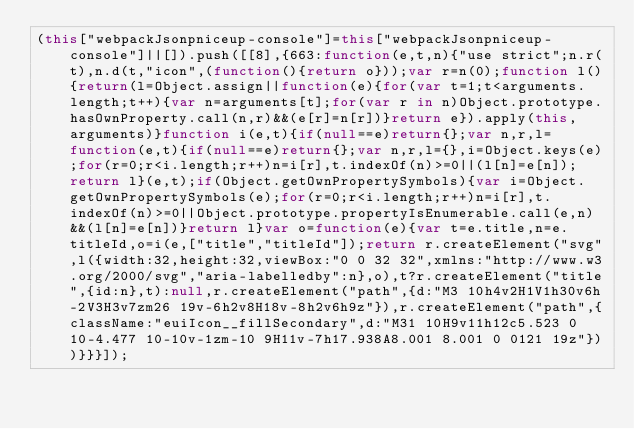Convert code to text. <code><loc_0><loc_0><loc_500><loc_500><_JavaScript_>(this["webpackJsonpniceup-console"]=this["webpackJsonpniceup-console"]||[]).push([[8],{663:function(e,t,n){"use strict";n.r(t),n.d(t,"icon",(function(){return o}));var r=n(0);function l(){return(l=Object.assign||function(e){for(var t=1;t<arguments.length;t++){var n=arguments[t];for(var r in n)Object.prototype.hasOwnProperty.call(n,r)&&(e[r]=n[r])}return e}).apply(this,arguments)}function i(e,t){if(null==e)return{};var n,r,l=function(e,t){if(null==e)return{};var n,r,l={},i=Object.keys(e);for(r=0;r<i.length;r++)n=i[r],t.indexOf(n)>=0||(l[n]=e[n]);return l}(e,t);if(Object.getOwnPropertySymbols){var i=Object.getOwnPropertySymbols(e);for(r=0;r<i.length;r++)n=i[r],t.indexOf(n)>=0||Object.prototype.propertyIsEnumerable.call(e,n)&&(l[n]=e[n])}return l}var o=function(e){var t=e.title,n=e.titleId,o=i(e,["title","titleId"]);return r.createElement("svg",l({width:32,height:32,viewBox:"0 0 32 32",xmlns:"http://www.w3.org/2000/svg","aria-labelledby":n},o),t?r.createElement("title",{id:n},t):null,r.createElement("path",{d:"M3 10h4v2H1V1h30v6h-2V3H3v7zm26 19v-6h2v8H18v-8h2v6h9z"}),r.createElement("path",{className:"euiIcon__fillSecondary",d:"M31 10H9v11h12c5.523 0 10-4.477 10-10v-1zm-10 9H11v-7h17.938A8.001 8.001 0 0121 19z"}))}}}]);</code> 